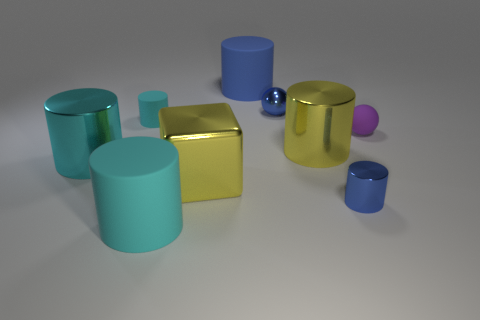Subtract all large metallic cylinders. How many cylinders are left? 4 Subtract 3 cylinders. How many cylinders are left? 3 Subtract all blue cylinders. How many cylinders are left? 4 Subtract all cylinders. How many objects are left? 3 Subtract all gray cylinders. Subtract all blue cubes. How many cylinders are left? 6 Subtract all purple blocks. How many purple cylinders are left? 0 Subtract all big cyan shiny cylinders. Subtract all cyan things. How many objects are left? 5 Add 5 big cyan things. How many big cyan things are left? 7 Add 7 tiny rubber balls. How many tiny rubber balls exist? 8 Subtract 1 purple balls. How many objects are left? 8 